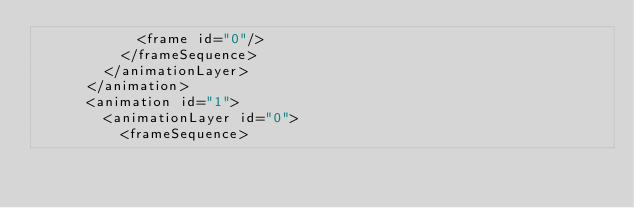<code> <loc_0><loc_0><loc_500><loc_500><_XML_>            <frame id="0"/>
          </frameSequence>
        </animationLayer>
      </animation>
      <animation id="1">
        <animationLayer id="0">
          <frameSequence></code> 